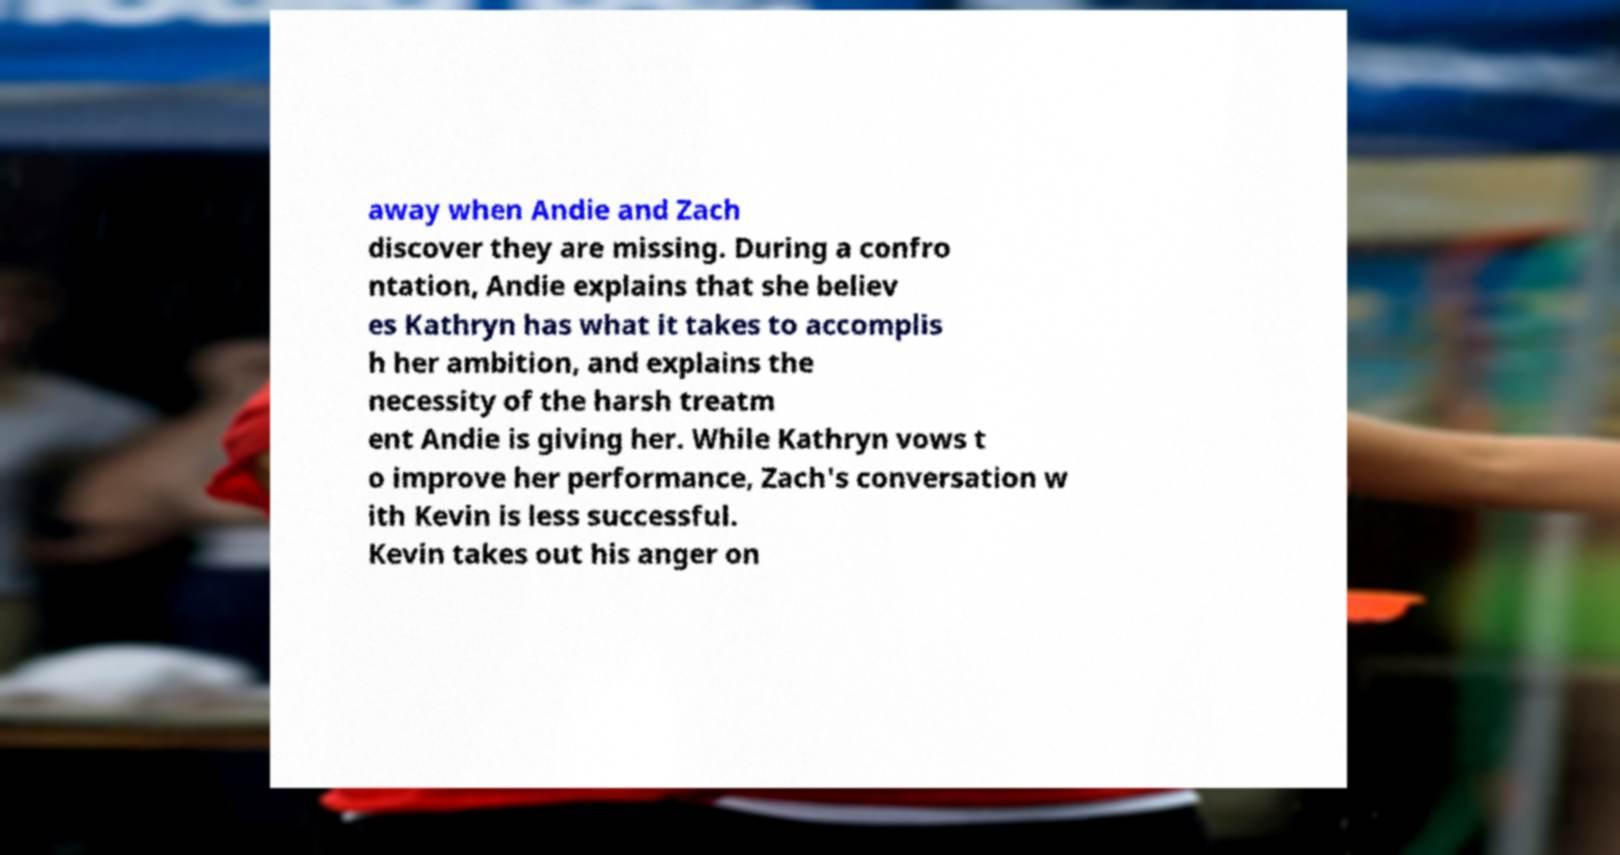What messages or text are displayed in this image? I need them in a readable, typed format. away when Andie and Zach discover they are missing. During a confro ntation, Andie explains that she believ es Kathryn has what it takes to accomplis h her ambition, and explains the necessity of the harsh treatm ent Andie is giving her. While Kathryn vows t o improve her performance, Zach's conversation w ith Kevin is less successful. Kevin takes out his anger on 